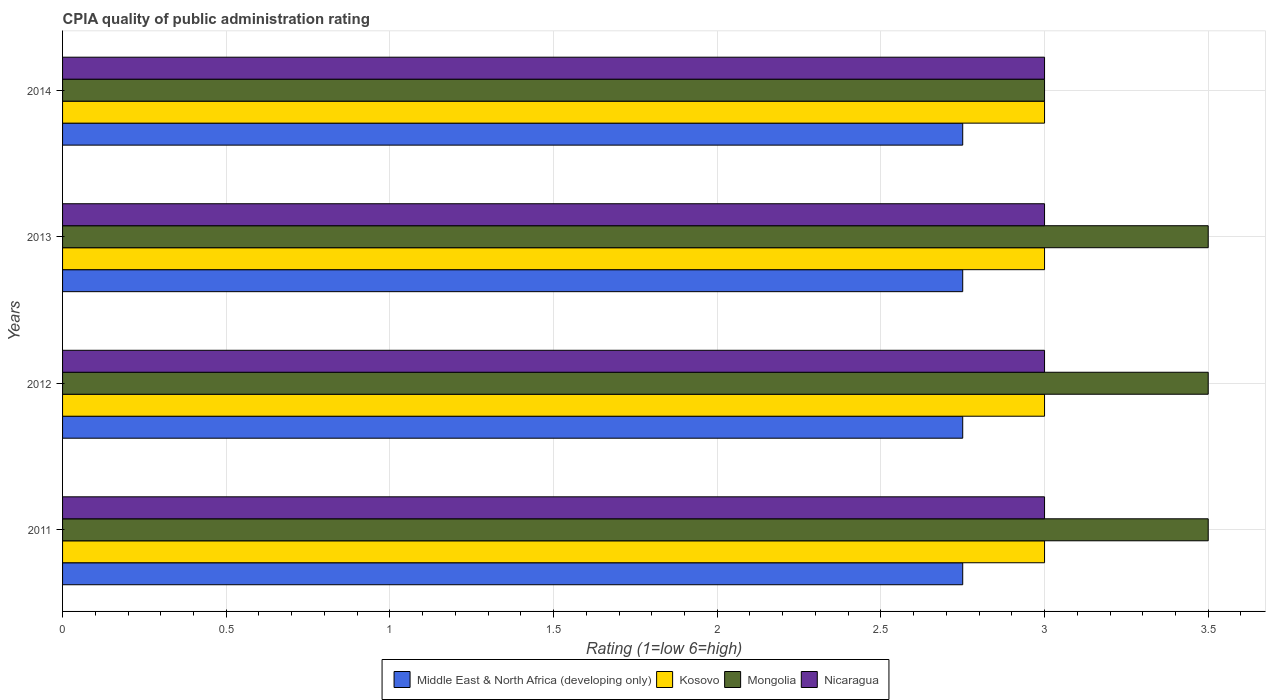How many groups of bars are there?
Ensure brevity in your answer.  4. Are the number of bars per tick equal to the number of legend labels?
Make the answer very short. Yes. How many bars are there on the 1st tick from the top?
Your answer should be compact. 4. How many bars are there on the 1st tick from the bottom?
Offer a terse response. 4. What is the label of the 1st group of bars from the top?
Provide a short and direct response. 2014. Across all years, what is the maximum CPIA rating in Mongolia?
Offer a terse response. 3.5. What is the total CPIA rating in Middle East & North Africa (developing only) in the graph?
Your answer should be compact. 11. What is the difference between the CPIA rating in Middle East & North Africa (developing only) in 2014 and the CPIA rating in Mongolia in 2012?
Your answer should be very brief. -0.75. What is the average CPIA rating in Nicaragua per year?
Offer a terse response. 3. What is the ratio of the CPIA rating in Middle East & North Africa (developing only) in 2012 to that in 2014?
Offer a terse response. 1. Is the difference between the CPIA rating in Mongolia in 2012 and 2014 greater than the difference between the CPIA rating in Nicaragua in 2012 and 2014?
Your answer should be compact. Yes. What is the difference between the highest and the second highest CPIA rating in Middle East & North Africa (developing only)?
Make the answer very short. 0. What does the 4th bar from the top in 2013 represents?
Give a very brief answer. Middle East & North Africa (developing only). What does the 4th bar from the bottom in 2014 represents?
Keep it short and to the point. Nicaragua. How many bars are there?
Your answer should be compact. 16. Are all the bars in the graph horizontal?
Make the answer very short. Yes. How many years are there in the graph?
Your answer should be compact. 4. What is the difference between two consecutive major ticks on the X-axis?
Provide a short and direct response. 0.5. Are the values on the major ticks of X-axis written in scientific E-notation?
Your response must be concise. No. Where does the legend appear in the graph?
Keep it short and to the point. Bottom center. How are the legend labels stacked?
Your answer should be very brief. Horizontal. What is the title of the graph?
Make the answer very short. CPIA quality of public administration rating. Does "Arab World" appear as one of the legend labels in the graph?
Make the answer very short. No. What is the label or title of the Y-axis?
Keep it short and to the point. Years. What is the Rating (1=low 6=high) of Middle East & North Africa (developing only) in 2011?
Give a very brief answer. 2.75. What is the Rating (1=low 6=high) of Middle East & North Africa (developing only) in 2012?
Make the answer very short. 2.75. What is the Rating (1=low 6=high) in Middle East & North Africa (developing only) in 2013?
Offer a terse response. 2.75. What is the Rating (1=low 6=high) of Nicaragua in 2013?
Your response must be concise. 3. What is the Rating (1=low 6=high) of Middle East & North Africa (developing only) in 2014?
Your response must be concise. 2.75. What is the Rating (1=low 6=high) of Nicaragua in 2014?
Offer a very short reply. 3. Across all years, what is the maximum Rating (1=low 6=high) in Middle East & North Africa (developing only)?
Ensure brevity in your answer.  2.75. Across all years, what is the maximum Rating (1=low 6=high) in Mongolia?
Your answer should be very brief. 3.5. Across all years, what is the minimum Rating (1=low 6=high) of Middle East & North Africa (developing only)?
Your answer should be compact. 2.75. Across all years, what is the minimum Rating (1=low 6=high) of Kosovo?
Your response must be concise. 3. Across all years, what is the minimum Rating (1=low 6=high) of Mongolia?
Ensure brevity in your answer.  3. Across all years, what is the minimum Rating (1=low 6=high) of Nicaragua?
Your response must be concise. 3. What is the total Rating (1=low 6=high) in Middle East & North Africa (developing only) in the graph?
Offer a terse response. 11. What is the total Rating (1=low 6=high) in Mongolia in the graph?
Your answer should be very brief. 13.5. What is the total Rating (1=low 6=high) in Nicaragua in the graph?
Your answer should be compact. 12. What is the difference between the Rating (1=low 6=high) in Kosovo in 2011 and that in 2013?
Offer a terse response. 0. What is the difference between the Rating (1=low 6=high) in Mongolia in 2011 and that in 2013?
Provide a succinct answer. 0. What is the difference between the Rating (1=low 6=high) of Nicaragua in 2011 and that in 2014?
Offer a very short reply. 0. What is the difference between the Rating (1=low 6=high) in Nicaragua in 2012 and that in 2013?
Provide a succinct answer. 0. What is the difference between the Rating (1=low 6=high) of Middle East & North Africa (developing only) in 2012 and that in 2014?
Your response must be concise. 0. What is the difference between the Rating (1=low 6=high) in Kosovo in 2012 and that in 2014?
Provide a short and direct response. 0. What is the difference between the Rating (1=low 6=high) of Nicaragua in 2012 and that in 2014?
Your response must be concise. 0. What is the difference between the Rating (1=low 6=high) of Middle East & North Africa (developing only) in 2013 and that in 2014?
Your response must be concise. 0. What is the difference between the Rating (1=low 6=high) of Kosovo in 2013 and that in 2014?
Give a very brief answer. 0. What is the difference between the Rating (1=low 6=high) of Mongolia in 2013 and that in 2014?
Your answer should be very brief. 0.5. What is the difference between the Rating (1=low 6=high) in Nicaragua in 2013 and that in 2014?
Offer a terse response. 0. What is the difference between the Rating (1=low 6=high) in Middle East & North Africa (developing only) in 2011 and the Rating (1=low 6=high) in Mongolia in 2012?
Offer a terse response. -0.75. What is the difference between the Rating (1=low 6=high) of Middle East & North Africa (developing only) in 2011 and the Rating (1=low 6=high) of Nicaragua in 2012?
Keep it short and to the point. -0.25. What is the difference between the Rating (1=low 6=high) of Middle East & North Africa (developing only) in 2011 and the Rating (1=low 6=high) of Mongolia in 2013?
Make the answer very short. -0.75. What is the difference between the Rating (1=low 6=high) in Middle East & North Africa (developing only) in 2011 and the Rating (1=low 6=high) in Nicaragua in 2013?
Your response must be concise. -0.25. What is the difference between the Rating (1=low 6=high) of Middle East & North Africa (developing only) in 2011 and the Rating (1=low 6=high) of Kosovo in 2014?
Provide a short and direct response. -0.25. What is the difference between the Rating (1=low 6=high) of Kosovo in 2011 and the Rating (1=low 6=high) of Mongolia in 2014?
Your response must be concise. 0. What is the difference between the Rating (1=low 6=high) in Mongolia in 2011 and the Rating (1=low 6=high) in Nicaragua in 2014?
Ensure brevity in your answer.  0.5. What is the difference between the Rating (1=low 6=high) in Middle East & North Africa (developing only) in 2012 and the Rating (1=low 6=high) in Kosovo in 2013?
Give a very brief answer. -0.25. What is the difference between the Rating (1=low 6=high) in Middle East & North Africa (developing only) in 2012 and the Rating (1=low 6=high) in Mongolia in 2013?
Your answer should be compact. -0.75. What is the difference between the Rating (1=low 6=high) of Middle East & North Africa (developing only) in 2012 and the Rating (1=low 6=high) of Nicaragua in 2013?
Your answer should be very brief. -0.25. What is the difference between the Rating (1=low 6=high) in Mongolia in 2012 and the Rating (1=low 6=high) in Nicaragua in 2013?
Your response must be concise. 0.5. What is the difference between the Rating (1=low 6=high) in Middle East & North Africa (developing only) in 2012 and the Rating (1=low 6=high) in Kosovo in 2014?
Your answer should be compact. -0.25. What is the difference between the Rating (1=low 6=high) in Kosovo in 2012 and the Rating (1=low 6=high) in Mongolia in 2014?
Ensure brevity in your answer.  0. What is the difference between the Rating (1=low 6=high) of Mongolia in 2012 and the Rating (1=low 6=high) of Nicaragua in 2014?
Your response must be concise. 0.5. What is the difference between the Rating (1=low 6=high) in Middle East & North Africa (developing only) in 2013 and the Rating (1=low 6=high) in Kosovo in 2014?
Give a very brief answer. -0.25. What is the difference between the Rating (1=low 6=high) of Middle East & North Africa (developing only) in 2013 and the Rating (1=low 6=high) of Mongolia in 2014?
Offer a terse response. -0.25. What is the difference between the Rating (1=low 6=high) of Kosovo in 2013 and the Rating (1=low 6=high) of Mongolia in 2014?
Offer a very short reply. 0. What is the difference between the Rating (1=low 6=high) in Kosovo in 2013 and the Rating (1=low 6=high) in Nicaragua in 2014?
Offer a terse response. 0. What is the average Rating (1=low 6=high) of Middle East & North Africa (developing only) per year?
Give a very brief answer. 2.75. What is the average Rating (1=low 6=high) in Kosovo per year?
Your response must be concise. 3. What is the average Rating (1=low 6=high) in Mongolia per year?
Offer a terse response. 3.38. What is the average Rating (1=low 6=high) in Nicaragua per year?
Make the answer very short. 3. In the year 2011, what is the difference between the Rating (1=low 6=high) of Middle East & North Africa (developing only) and Rating (1=low 6=high) of Kosovo?
Make the answer very short. -0.25. In the year 2011, what is the difference between the Rating (1=low 6=high) in Middle East & North Africa (developing only) and Rating (1=low 6=high) in Mongolia?
Offer a very short reply. -0.75. In the year 2011, what is the difference between the Rating (1=low 6=high) in Middle East & North Africa (developing only) and Rating (1=low 6=high) in Nicaragua?
Keep it short and to the point. -0.25. In the year 2011, what is the difference between the Rating (1=low 6=high) of Kosovo and Rating (1=low 6=high) of Nicaragua?
Make the answer very short. 0. In the year 2012, what is the difference between the Rating (1=low 6=high) of Middle East & North Africa (developing only) and Rating (1=low 6=high) of Kosovo?
Your answer should be very brief. -0.25. In the year 2012, what is the difference between the Rating (1=low 6=high) of Middle East & North Africa (developing only) and Rating (1=low 6=high) of Mongolia?
Your response must be concise. -0.75. In the year 2012, what is the difference between the Rating (1=low 6=high) in Middle East & North Africa (developing only) and Rating (1=low 6=high) in Nicaragua?
Keep it short and to the point. -0.25. In the year 2012, what is the difference between the Rating (1=low 6=high) in Kosovo and Rating (1=low 6=high) in Nicaragua?
Give a very brief answer. 0. In the year 2013, what is the difference between the Rating (1=low 6=high) in Middle East & North Africa (developing only) and Rating (1=low 6=high) in Mongolia?
Your response must be concise. -0.75. In the year 2013, what is the difference between the Rating (1=low 6=high) in Middle East & North Africa (developing only) and Rating (1=low 6=high) in Nicaragua?
Keep it short and to the point. -0.25. In the year 2013, what is the difference between the Rating (1=low 6=high) of Kosovo and Rating (1=low 6=high) of Mongolia?
Your response must be concise. -0.5. In the year 2013, what is the difference between the Rating (1=low 6=high) in Kosovo and Rating (1=low 6=high) in Nicaragua?
Keep it short and to the point. 0. In the year 2013, what is the difference between the Rating (1=low 6=high) of Mongolia and Rating (1=low 6=high) of Nicaragua?
Keep it short and to the point. 0.5. In the year 2014, what is the difference between the Rating (1=low 6=high) of Middle East & North Africa (developing only) and Rating (1=low 6=high) of Nicaragua?
Your response must be concise. -0.25. What is the ratio of the Rating (1=low 6=high) in Kosovo in 2011 to that in 2012?
Keep it short and to the point. 1. What is the ratio of the Rating (1=low 6=high) in Mongolia in 2011 to that in 2012?
Give a very brief answer. 1. What is the ratio of the Rating (1=low 6=high) of Nicaragua in 2011 to that in 2012?
Provide a succinct answer. 1. What is the ratio of the Rating (1=low 6=high) in Mongolia in 2011 to that in 2013?
Make the answer very short. 1. What is the ratio of the Rating (1=low 6=high) of Nicaragua in 2011 to that in 2013?
Your answer should be very brief. 1. What is the ratio of the Rating (1=low 6=high) in Kosovo in 2011 to that in 2014?
Your answer should be very brief. 1. What is the ratio of the Rating (1=low 6=high) of Mongolia in 2011 to that in 2014?
Give a very brief answer. 1.17. What is the ratio of the Rating (1=low 6=high) of Nicaragua in 2011 to that in 2014?
Make the answer very short. 1. What is the ratio of the Rating (1=low 6=high) of Nicaragua in 2012 to that in 2013?
Your response must be concise. 1. What is the ratio of the Rating (1=low 6=high) in Mongolia in 2013 to that in 2014?
Ensure brevity in your answer.  1.17. What is the ratio of the Rating (1=low 6=high) in Nicaragua in 2013 to that in 2014?
Make the answer very short. 1. 